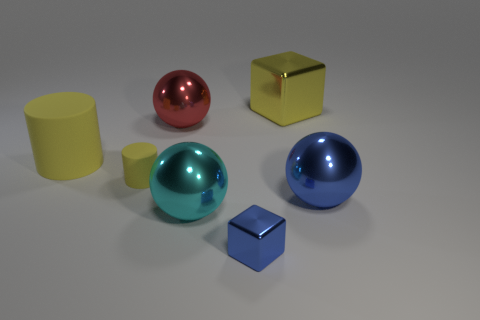Add 1 big matte things. How many objects exist? 8 Subtract all spheres. How many objects are left? 4 Add 7 cyan metal things. How many cyan metal things exist? 8 Subtract 0 gray blocks. How many objects are left? 7 Subtract all large red shiny cylinders. Subtract all cubes. How many objects are left? 5 Add 5 blue cubes. How many blue cubes are left? 6 